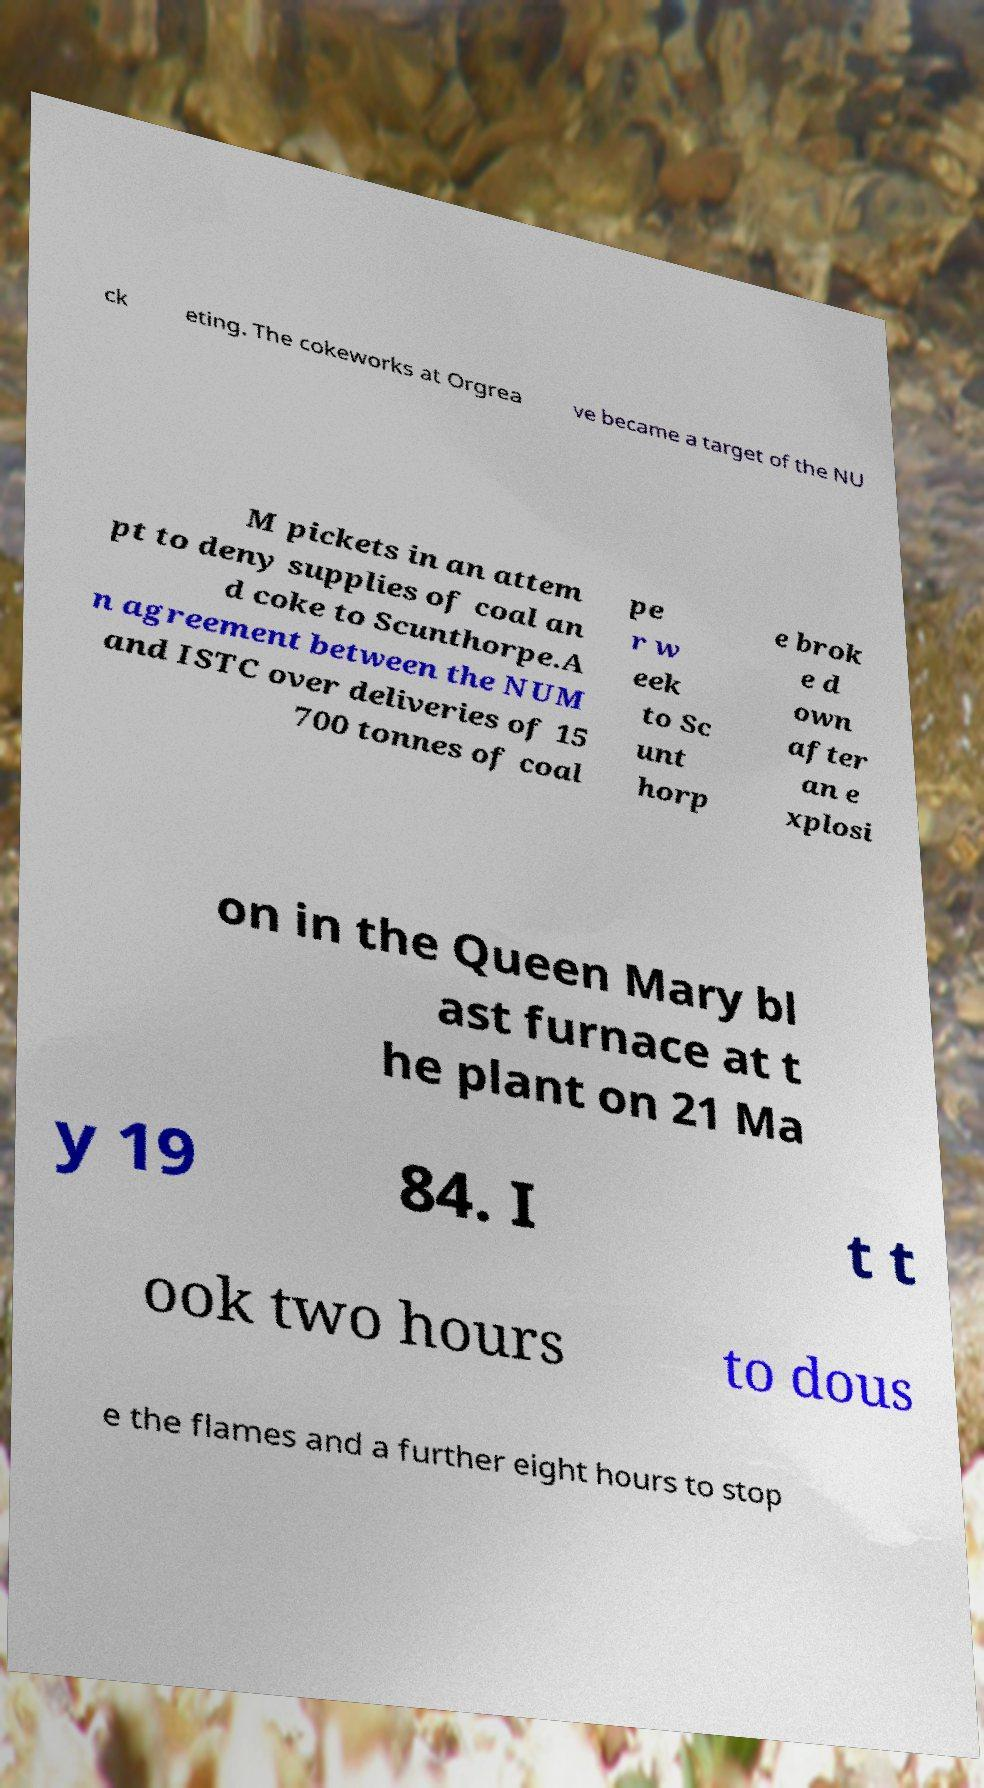Please identify and transcribe the text found in this image. ck eting. The cokeworks at Orgrea ve became a target of the NU M pickets in an attem pt to deny supplies of coal an d coke to Scunthorpe.A n agreement between the NUM and ISTC over deliveries of 15 700 tonnes of coal pe r w eek to Sc unt horp e brok e d own after an e xplosi on in the Queen Mary bl ast furnace at t he plant on 21 Ma y 19 84. I t t ook two hours to dous e the flames and a further eight hours to stop 